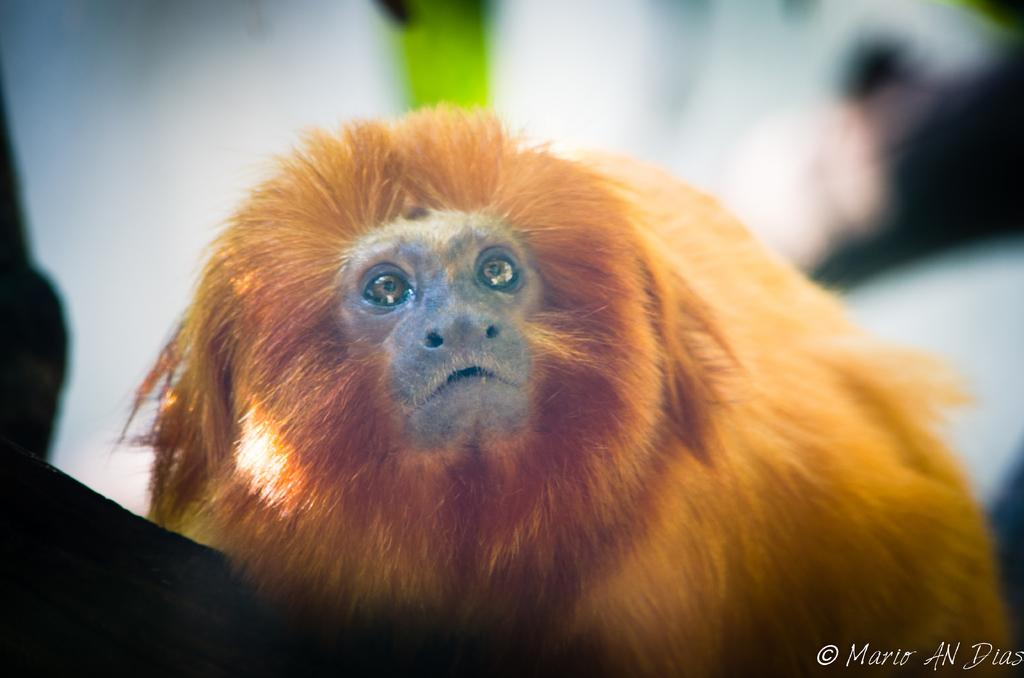What type of animal is in the image? There is a monkey in the image. What color is the monkey? The monkey is brown in color. Can you describe the background of the image? The background of the image is blurred. How many crates are stacked next to the monkey in the image? There are no crates present in the image. What day of the week is depicted in the image? The image does not depict a specific day of the week. 